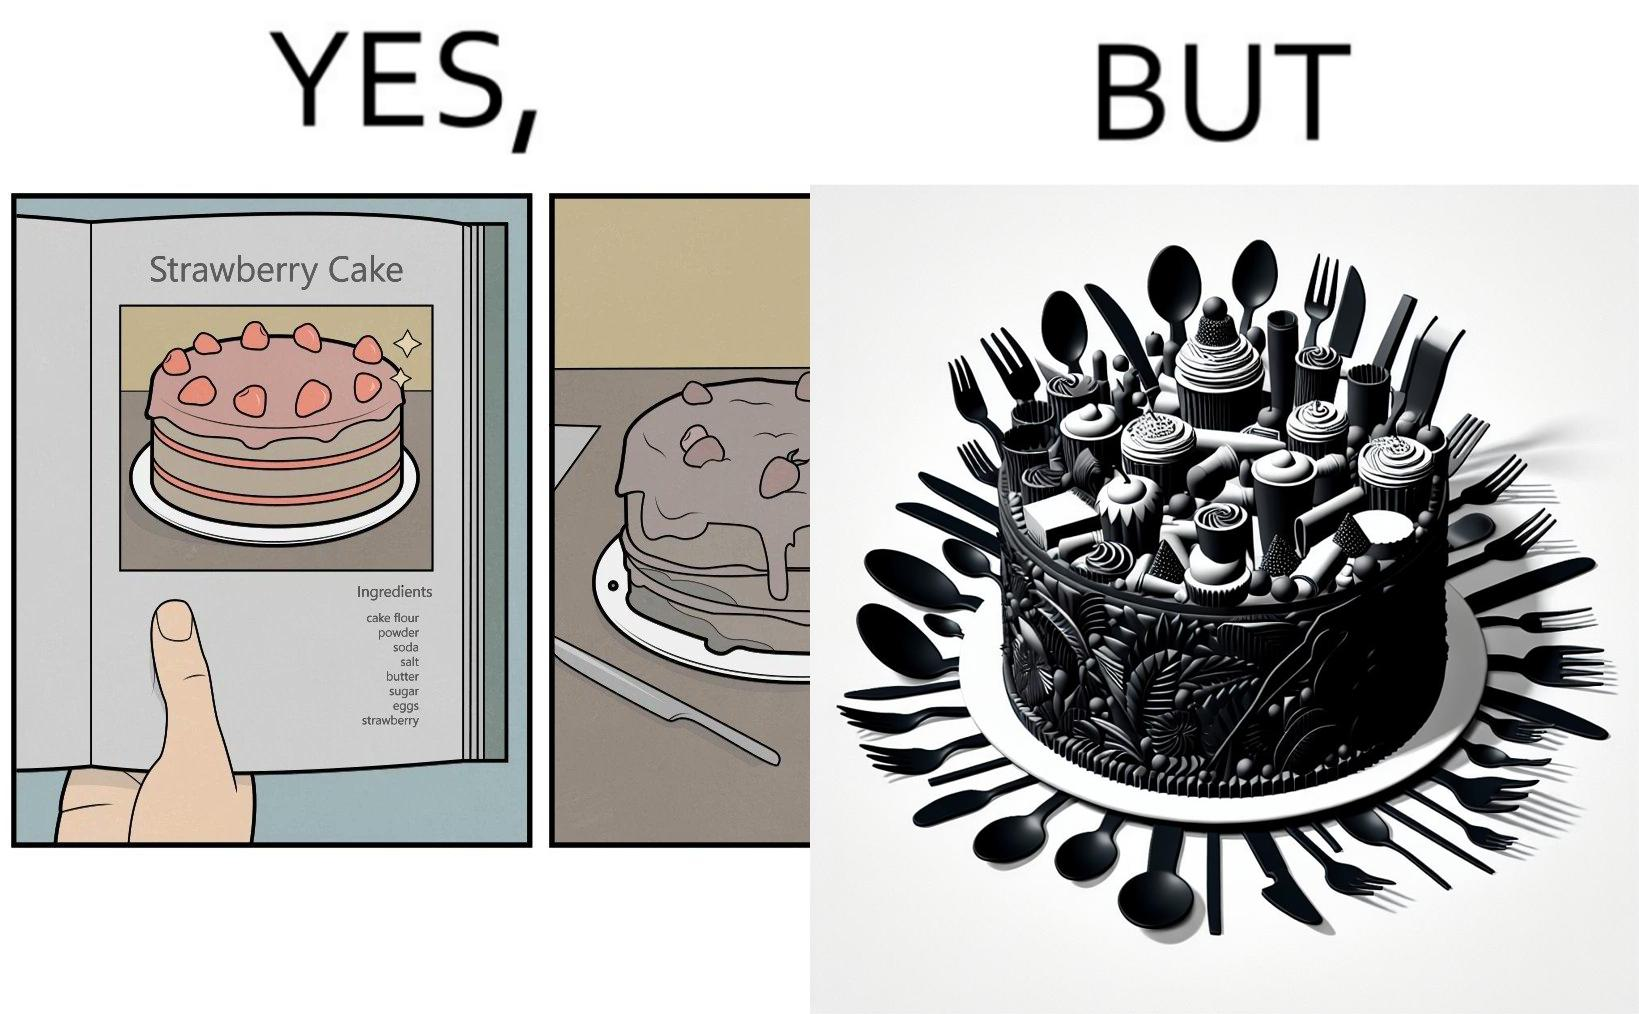Would you classify this image as satirical? Yes, this image is satirical. 